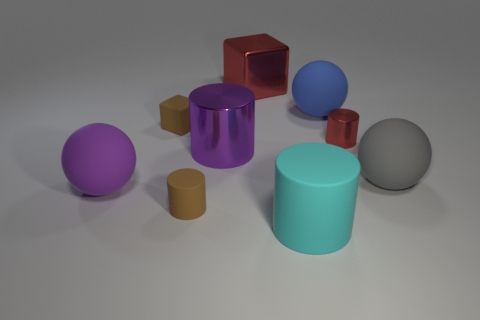Subtract 1 cylinders. How many cylinders are left? 3 Add 1 tiny blue spheres. How many objects exist? 10 Subtract all balls. How many objects are left? 6 Subtract 0 gray cylinders. How many objects are left? 9 Subtract all gray metal objects. Subtract all blue objects. How many objects are left? 8 Add 1 big red metallic objects. How many big red metallic objects are left? 2 Add 4 rubber balls. How many rubber balls exist? 7 